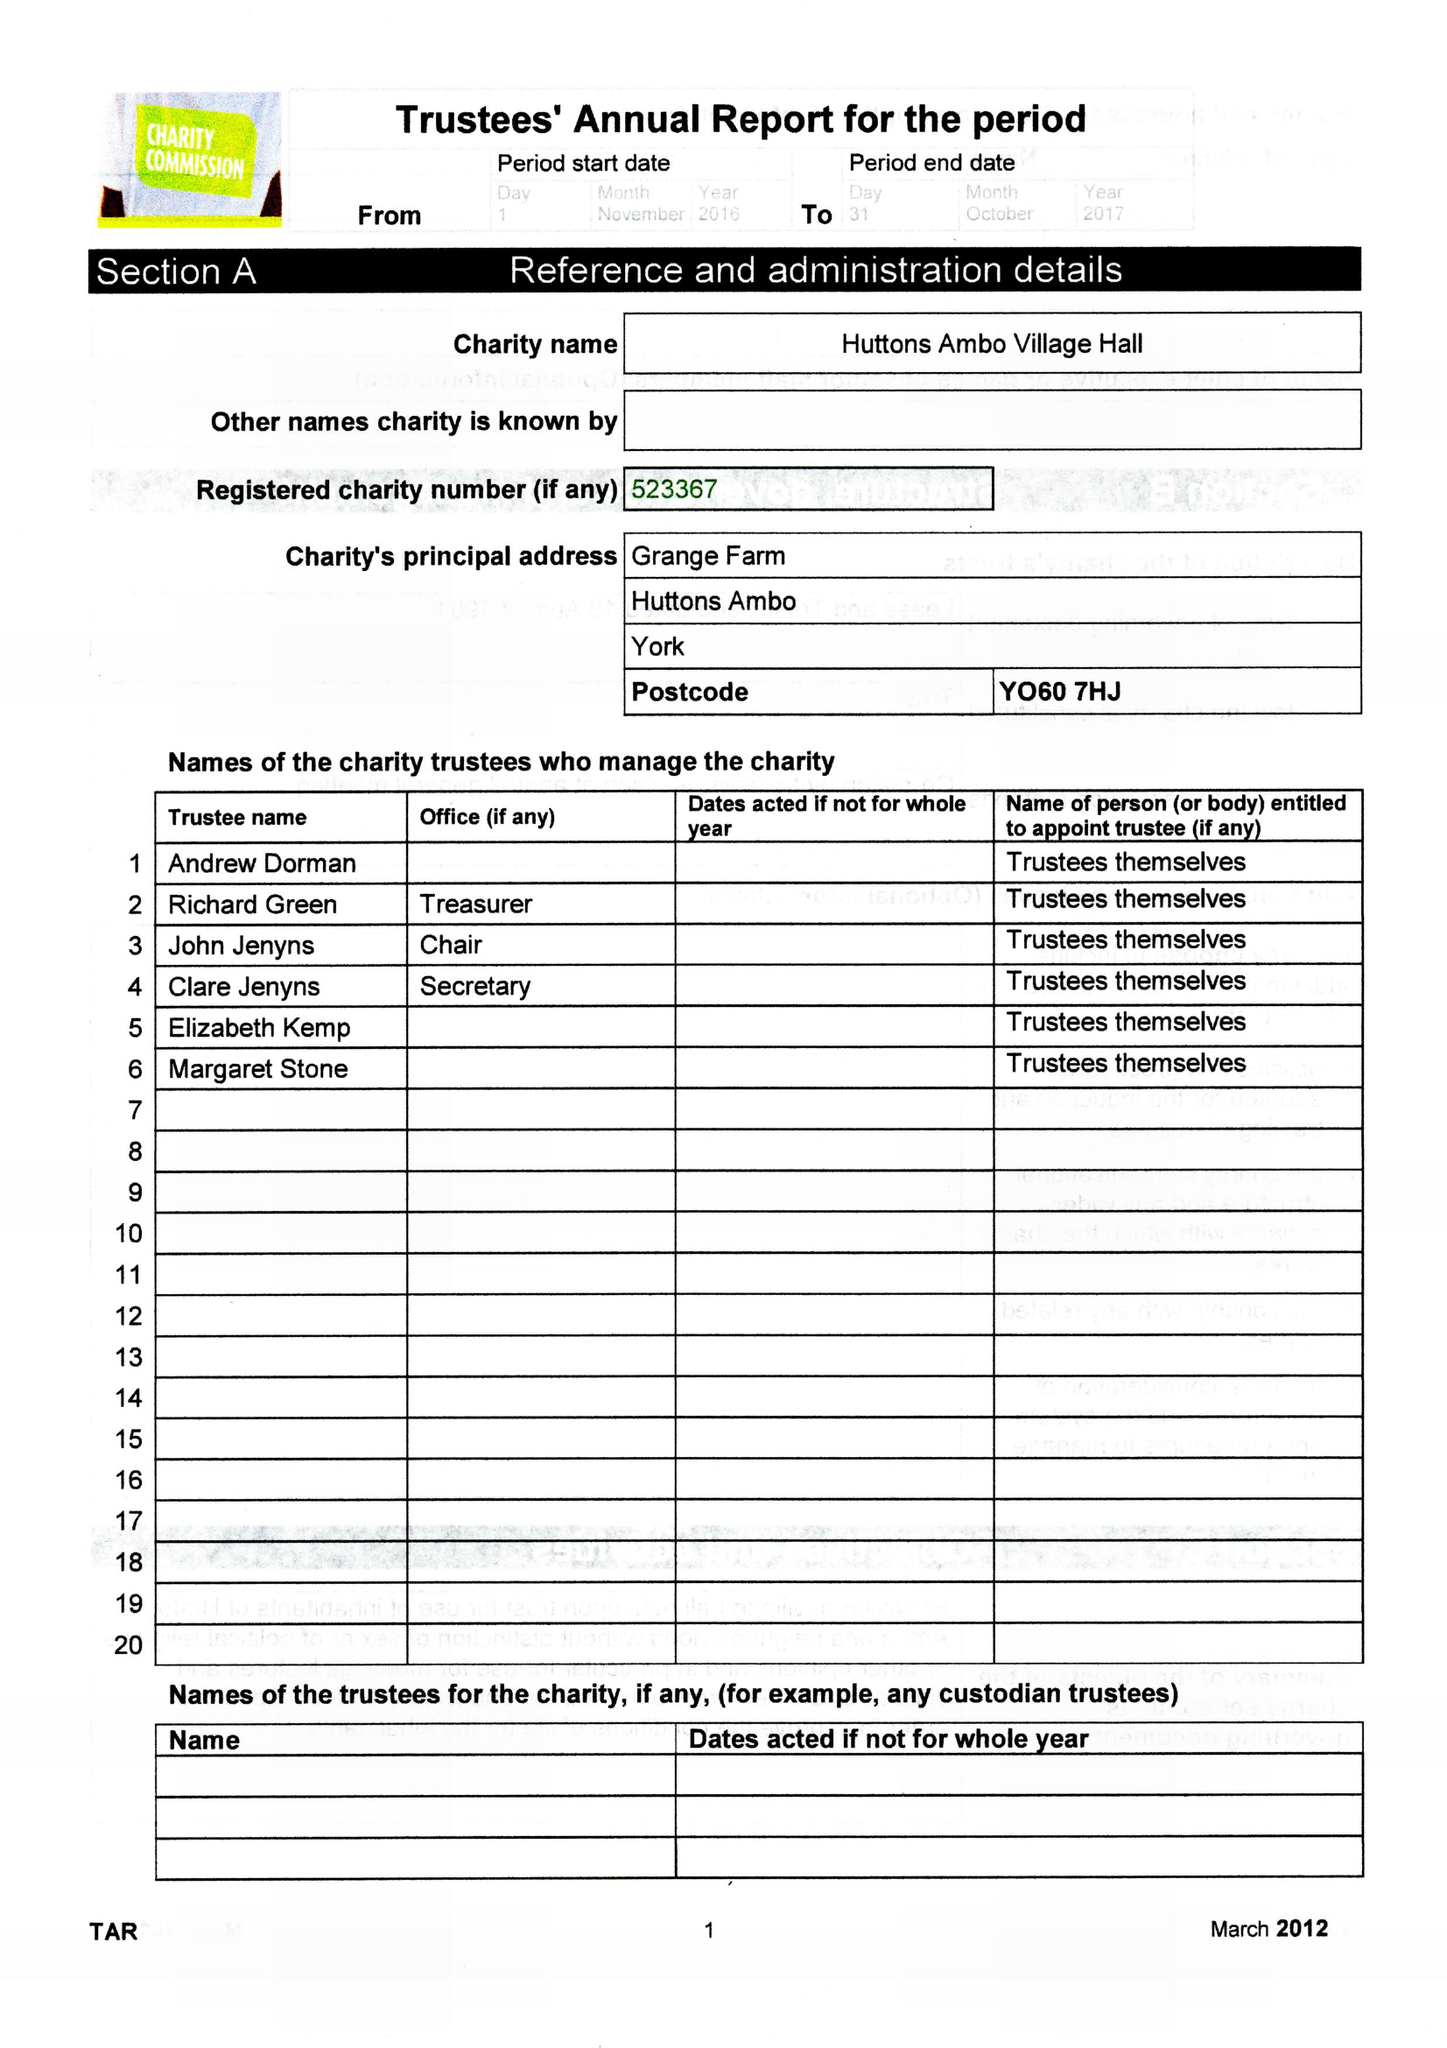What is the value for the spending_annually_in_british_pounds?
Answer the question using a single word or phrase. 176579.00 